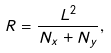Convert formula to latex. <formula><loc_0><loc_0><loc_500><loc_500>R = \frac { L ^ { 2 } } { N _ { x } + N _ { y } } ,</formula> 